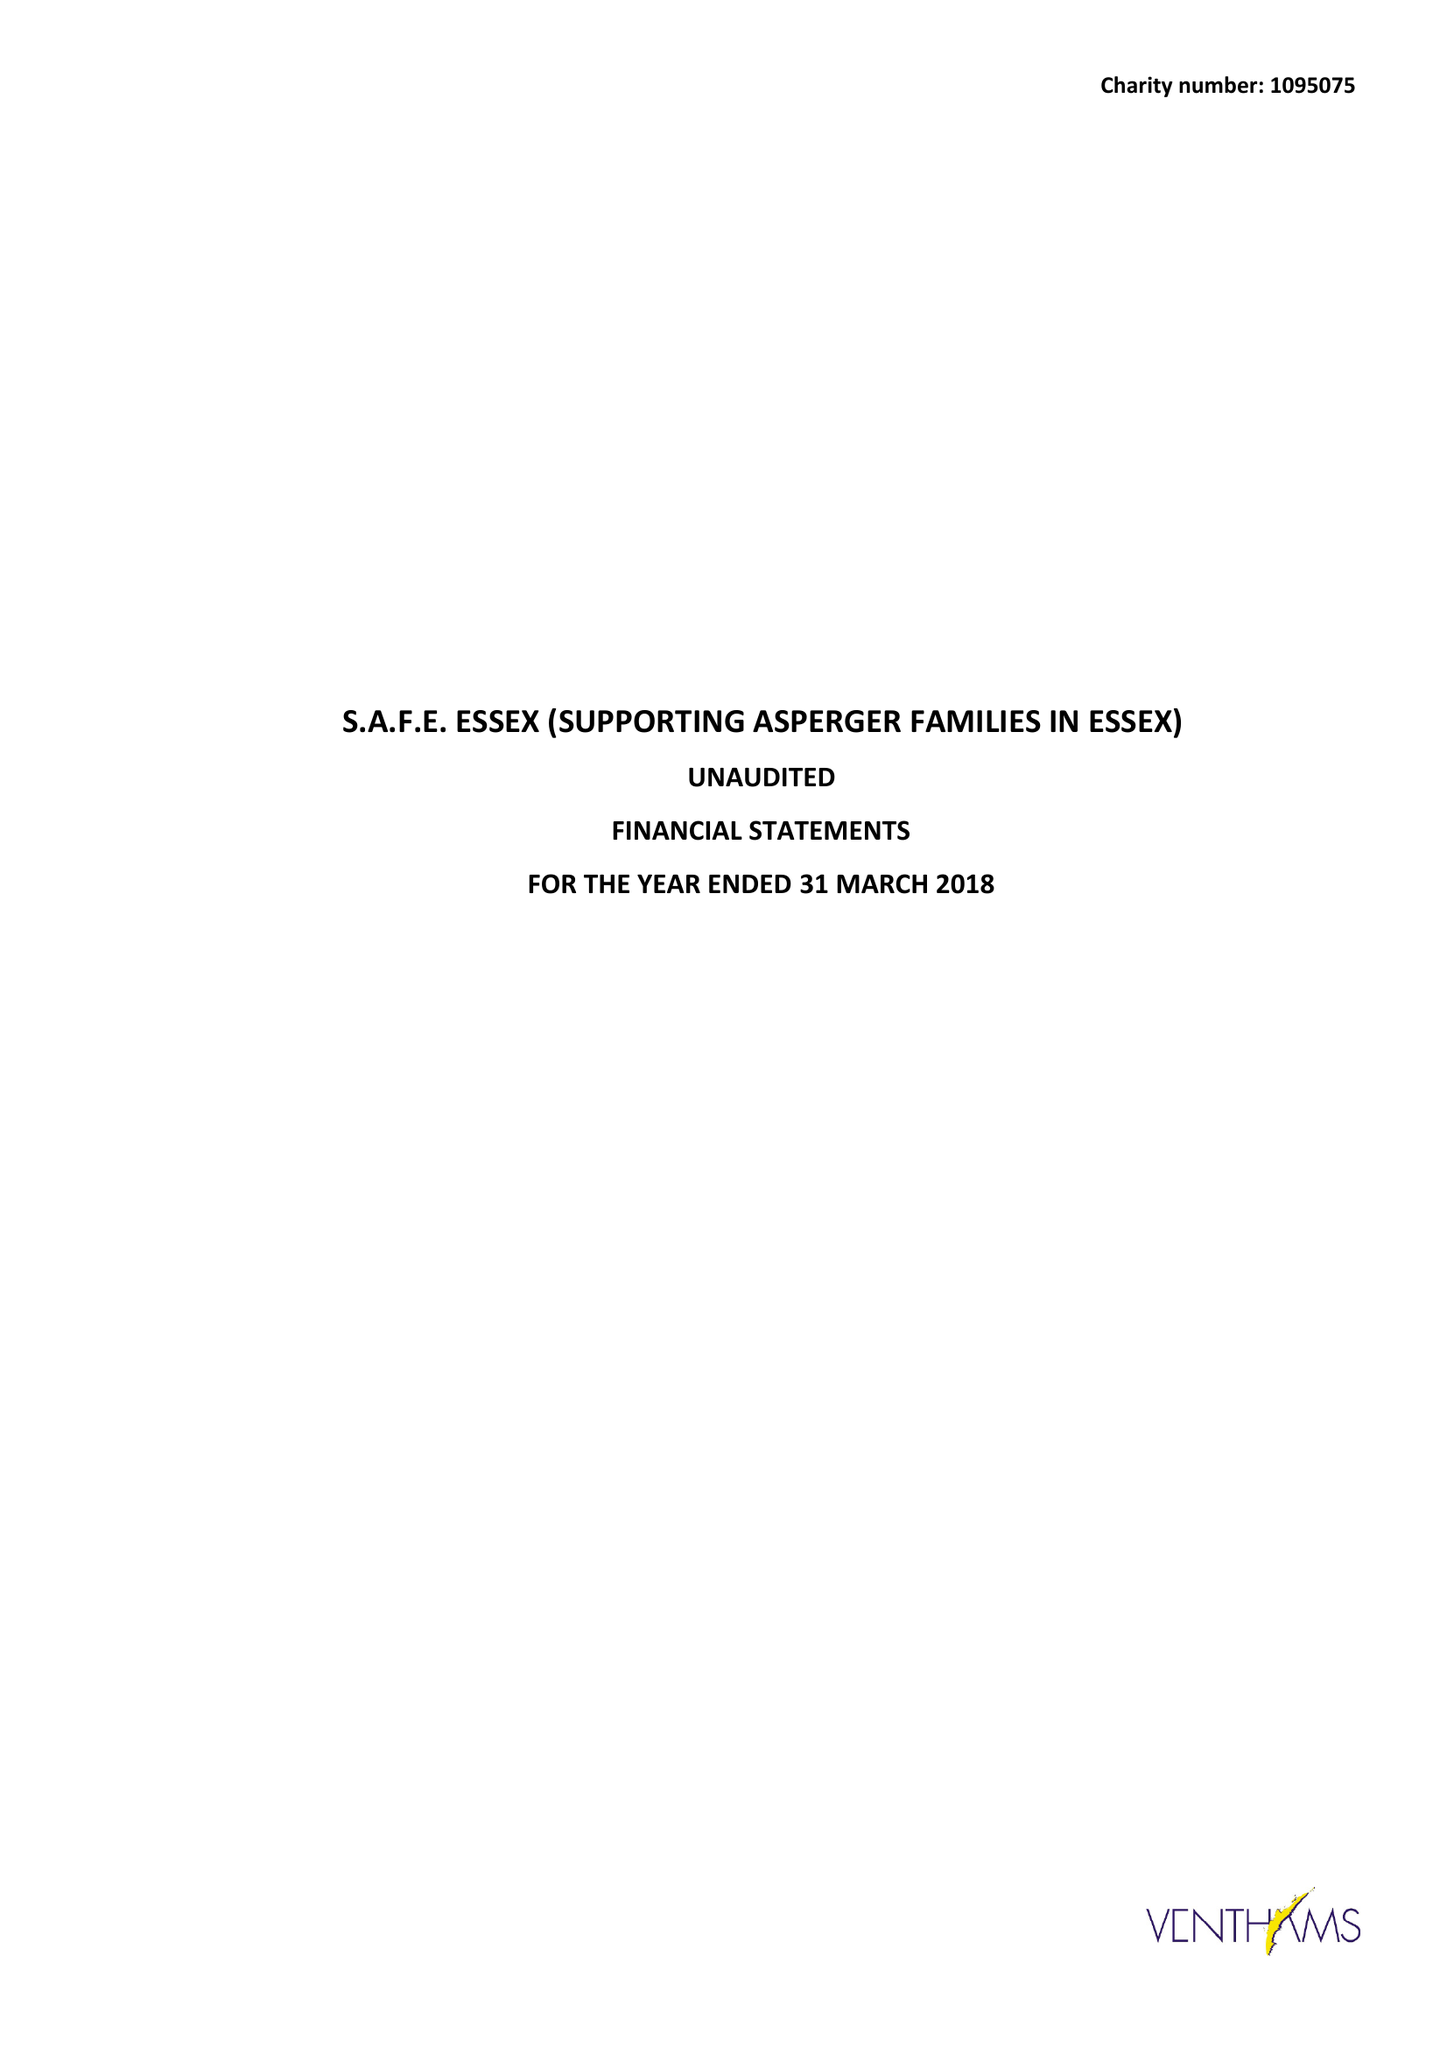What is the value for the address__street_line?
Answer the question using a single word or phrase. 22 TUSSER CLOSE 